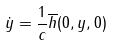Convert formula to latex. <formula><loc_0><loc_0><loc_500><loc_500>\dot { y } = \frac { 1 } { c } \overline { h } ( 0 , y , 0 )</formula> 